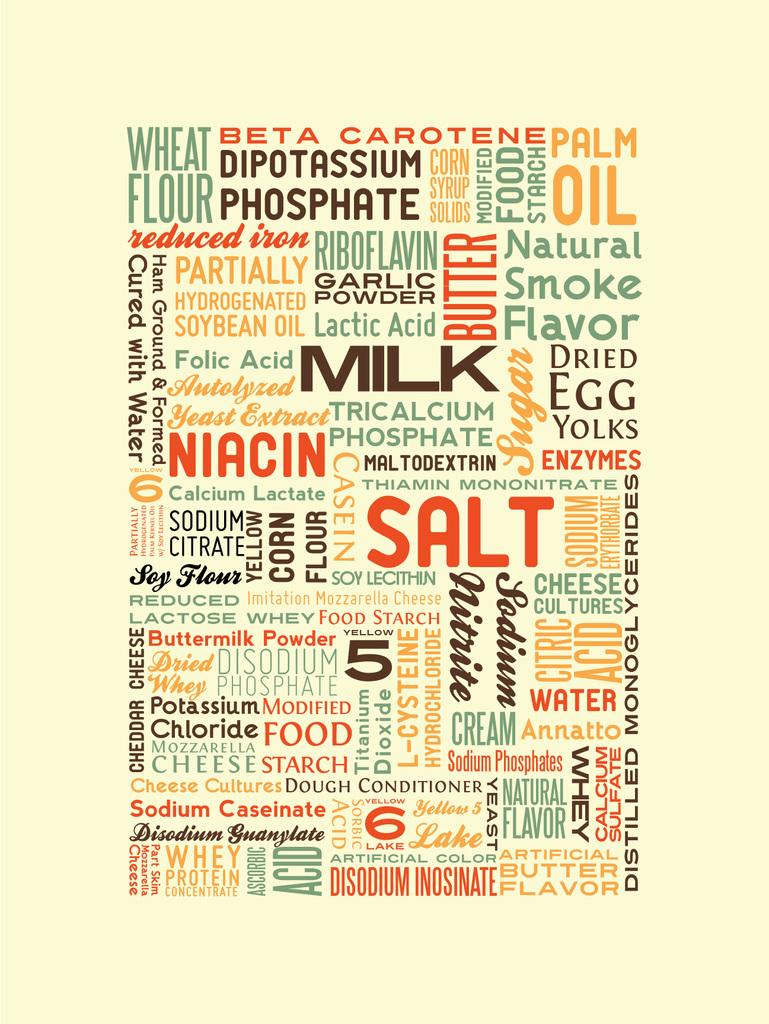<image>
Share a concise interpretation of the image provided. Several food ingredients are listed in a typographical poster design. 